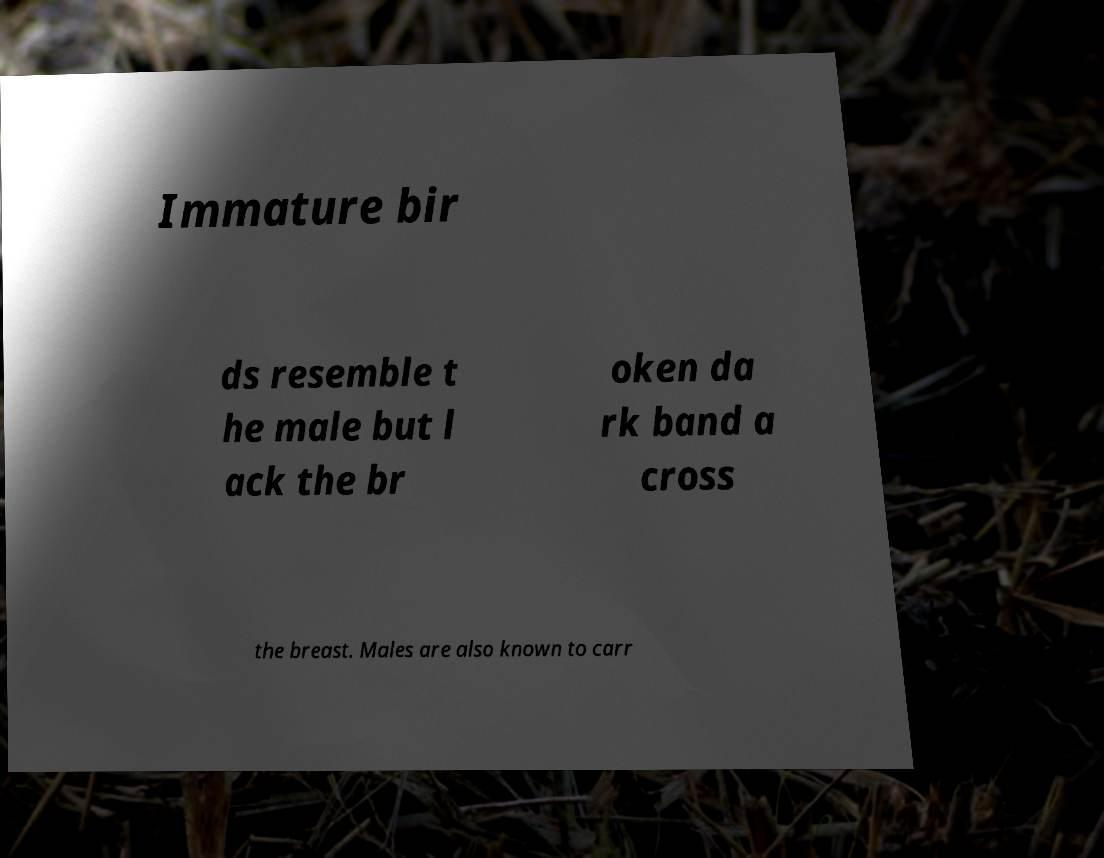Please read and relay the text visible in this image. What does it say? Immature bir ds resemble t he male but l ack the br oken da rk band a cross the breast. Males are also known to carr 